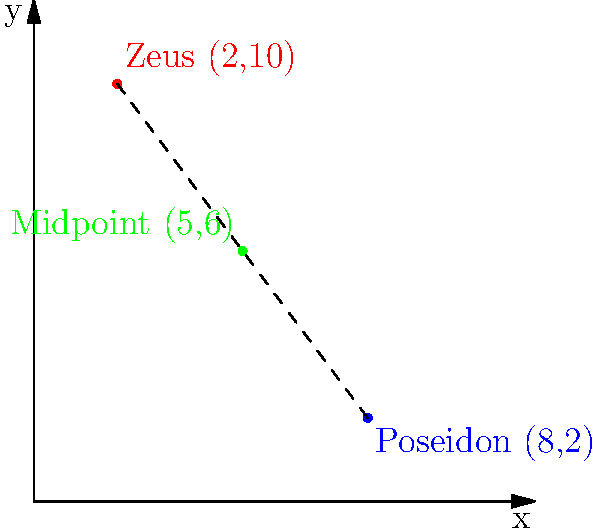In the epic tale of Greek mythology, Zeus rules from Mount Olympus while Poseidon reigns over the sea. On our coordinate plane, Zeus is located at (2,10) and Poseidon at (8,2). Can you help find the midpoint between these two powerful gods? This point could represent a neutral meeting ground for the brothers to discuss important matters of the cosmos! To find the midpoint between two points, we can use the midpoint formula:

$$ \text{Midpoint} = (\frac{x_1 + x_2}{2}, \frac{y_1 + y_2}{2}) $$

Where $(x_1, y_1)$ is the first point and $(x_2, y_2)$ is the second point.

Let's plug in our values:
Zeus: $(x_1, y_1) = (2, 10)$
Poseidon: $(x_2, y_2) = (8, 2)$

Now, let's calculate:

1) For the x-coordinate:
   $\frac{x_1 + x_2}{2} = \frac{2 + 8}{2} = \frac{10}{2} = 5$

2) For the y-coordinate:
   $\frac{y_1 + y_2}{2} = \frac{10 + 2}{2} = \frac{12}{2} = 6$

Therefore, the midpoint between Zeus and Poseidon is (5,6).
Answer: (5,6) 